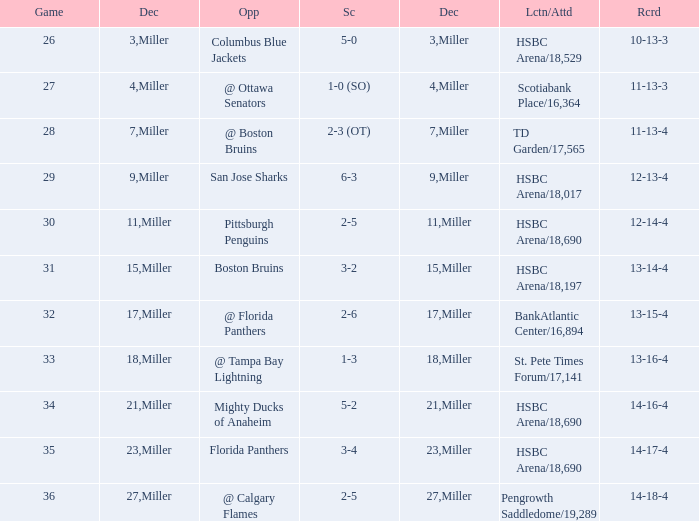Name the least december for hsbc arena/18,017 9.0. 